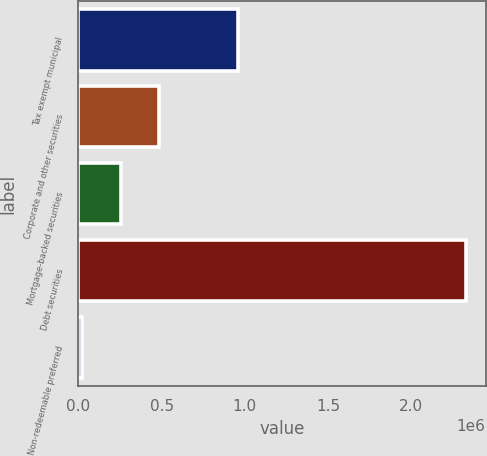Convert chart to OTSL. <chart><loc_0><loc_0><loc_500><loc_500><bar_chart><fcel>Tax exempt municipal<fcel>Corporate and other securities<fcel>Mortgage-backed securities<fcel>Debt securities<fcel>Non-redeemable preferred<nl><fcel>960805<fcel>485385<fcel>254696<fcel>2.3309e+06<fcel>24007<nl></chart> 